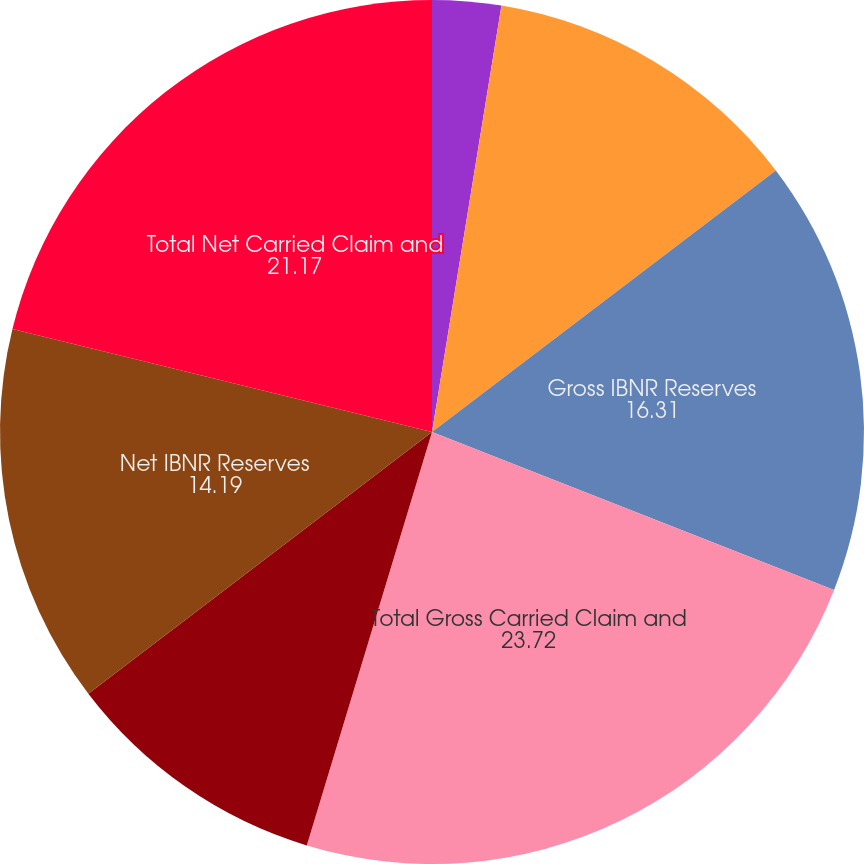<chart> <loc_0><loc_0><loc_500><loc_500><pie_chart><fcel>December 31<fcel>Gross Case Reserves<fcel>Gross IBNR Reserves<fcel>Total Gross Carried Claim and<fcel>Net Case Reserves<fcel>Net IBNR Reserves<fcel>Total Net Carried Claim and<nl><fcel>2.57%<fcel>12.08%<fcel>16.31%<fcel>23.72%<fcel>9.96%<fcel>14.19%<fcel>21.17%<nl></chart> 